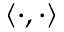<formula> <loc_0><loc_0><loc_500><loc_500>\left < \cdot , \cdot \right ></formula> 